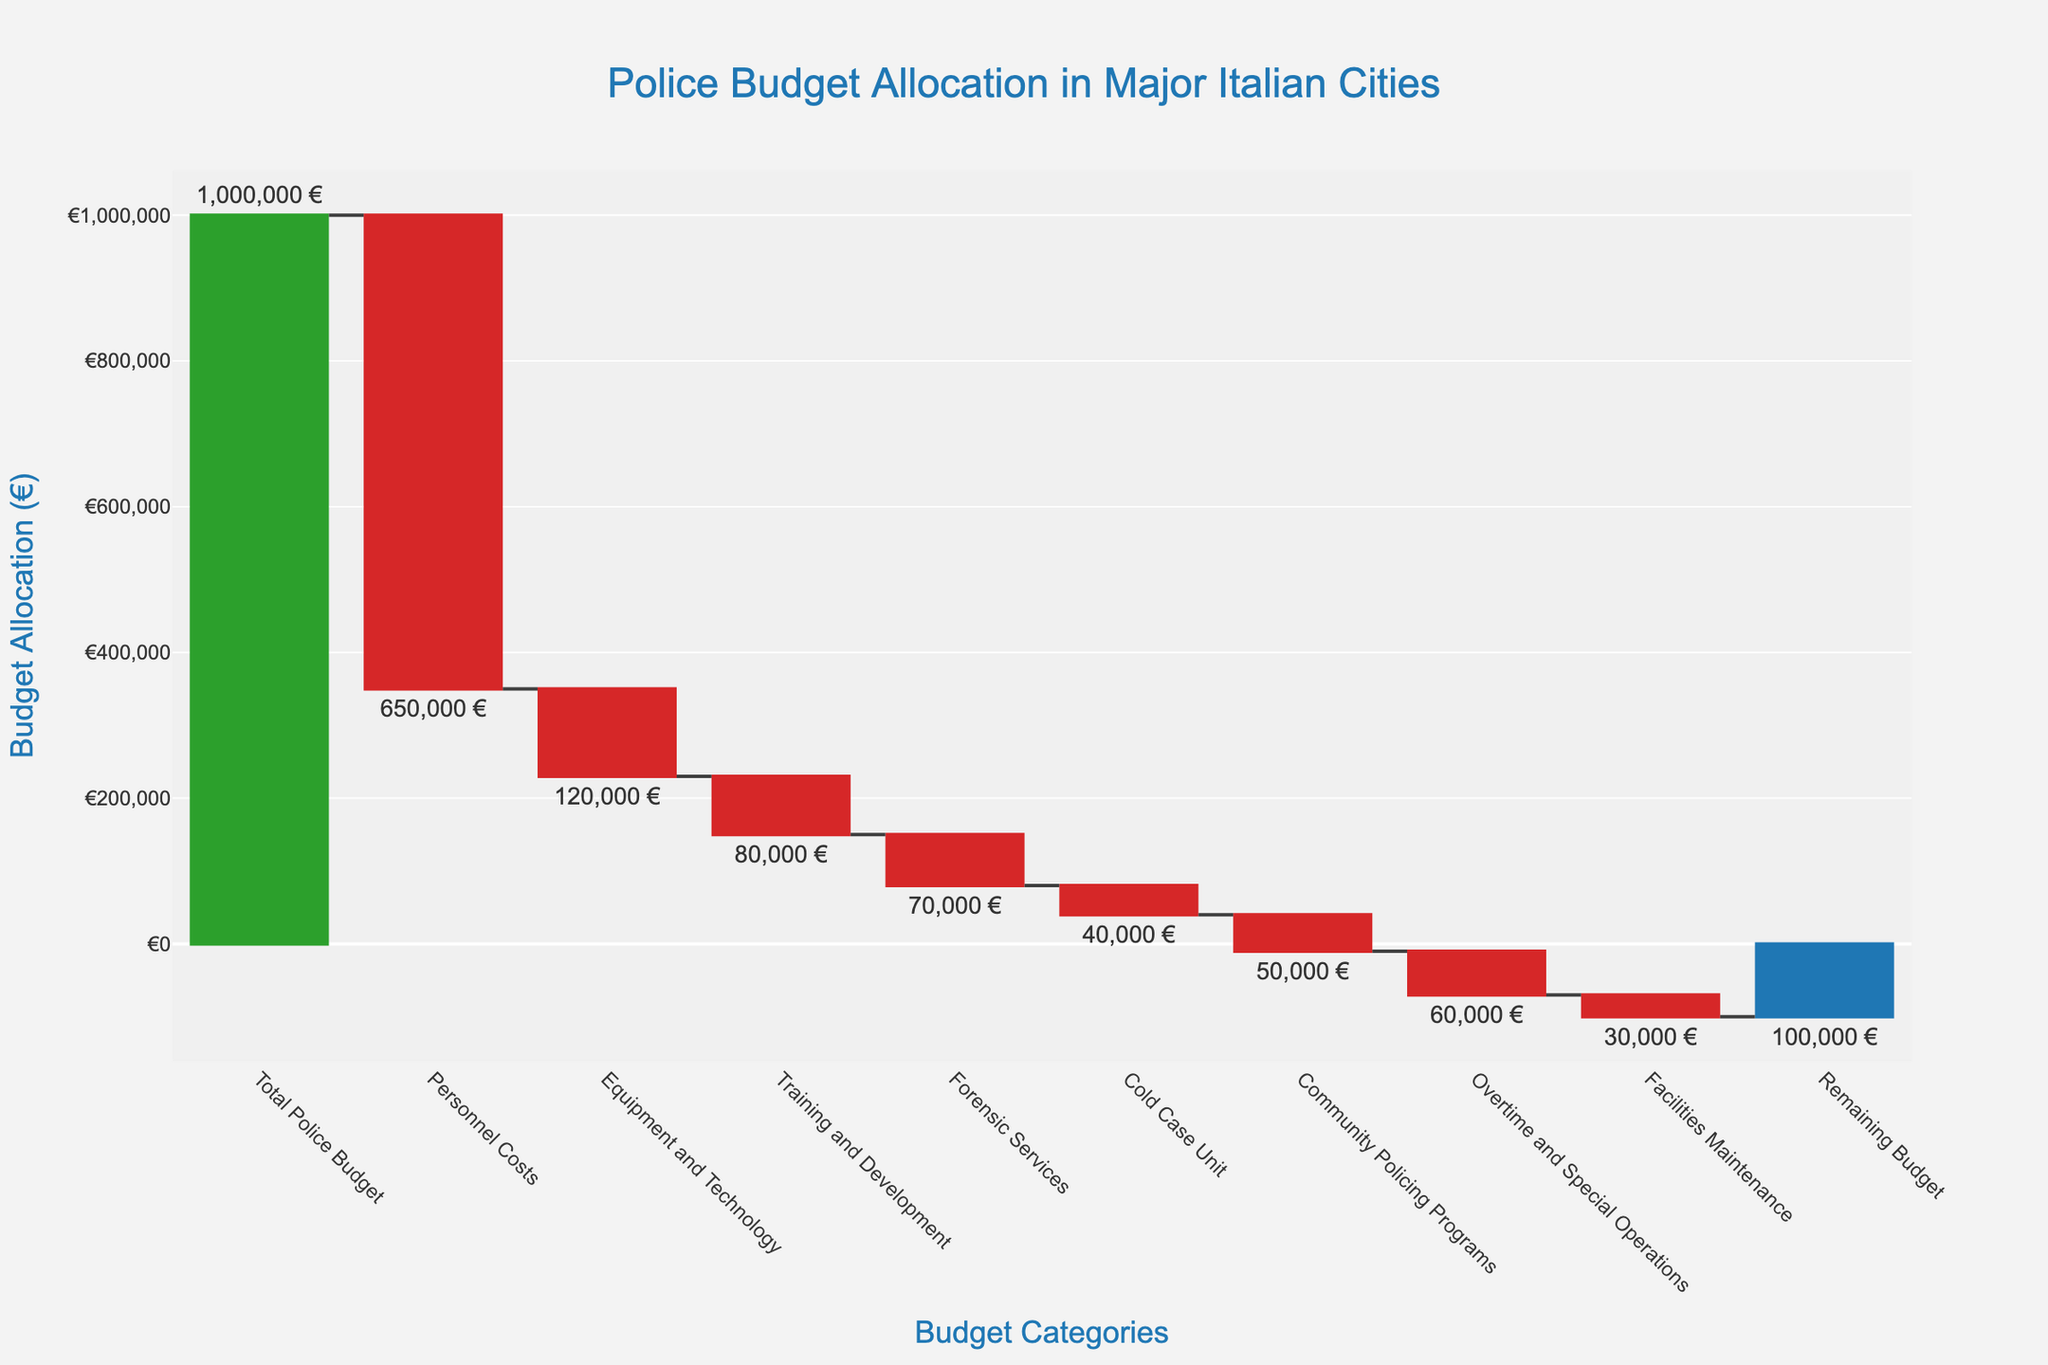What's the title of the chart? The title is usually located at the top of the chart. In this case, the title is "Police Budget Allocation in Major Italian Cities." This concise information provides an overview of what the chart is depicting.
Answer: Police Budget Allocation in Major Italian Cities What is the total police budget allocated? The total police budget allocated is the very first bar in the chart, often marked distinctly differently from the other categories. It reads €1,000,000.
Answer: €1,000,000 How much budget is remaining after all allocations? The remaining budget is the last bar in a waterfall chart, which shows the net result after all allocations. It reads -€100,000.
Answer: -€100,000 Which category has the largest allocation? By comparing the length of the bars representing various categories, the Personnel Costs bar is the longest at -€650,000, indicating the largest allocation.
Answer: Personnel Costs How much is allocated to the Cold Case Unit? The bar labeled Cold Case Unit is associated with a value. The allocated amount is -€40,000.
Answer: -€40,000 How much more is allocated to Equipment and Technology than to Community Policing Programs? Subtract the Community Policing Programs allocation (-€50,000) from the Equipment and Technology allocation (-€120,000). The difference is €70,000.
Answer: €70,000 What is the difference in budget allocation between Training and Development and Forensic Services? The Training and Development budget is -€80,000 and the Forensic Services budget is -€70,000. The difference is -€80,000 - (-€70,000) = -€10,000.
Answer: -€10,000 If the Personnel Costs increased by €50,000, what would be the revised total remaining budget? Current remaining budget is -€100,000. If Personnel Costs increased by €50,000, the new allocation would be -€650,000 - €50,000 = -€700,000. Update remaining budget: -€100,000 - €50,000 = -€150,000.
Answer: -€150,000 Which category received more funds, Overtime and Special Operations or Forensic Services? By comparing the two bars, Forensic Services is -€70,000, and Overtime and Special Operations is -€60,000. Therefore, Forensic Services received more funds.
Answer: Forensic Services How much is allocated to Facilities Maintenance and Training and Development combined? Sum the values for Facilities Maintenance (-€30,000) and Training and Development (-€80,000). -€30,000 + -€80,000 = -€110,000.
Answer: -€110,000 